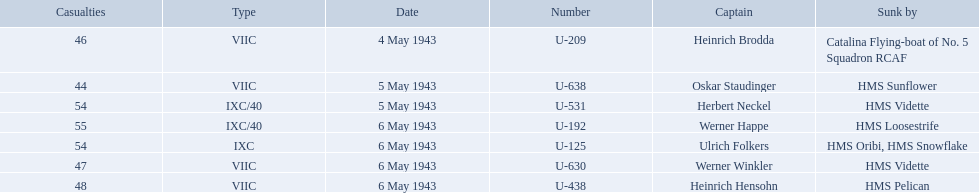What boats were lost on may 5? U-638, U-531. Who were the captains of those boats? Oskar Staudinger, Herbert Neckel. Which captain was not oskar staudinger? Herbert Neckel. 